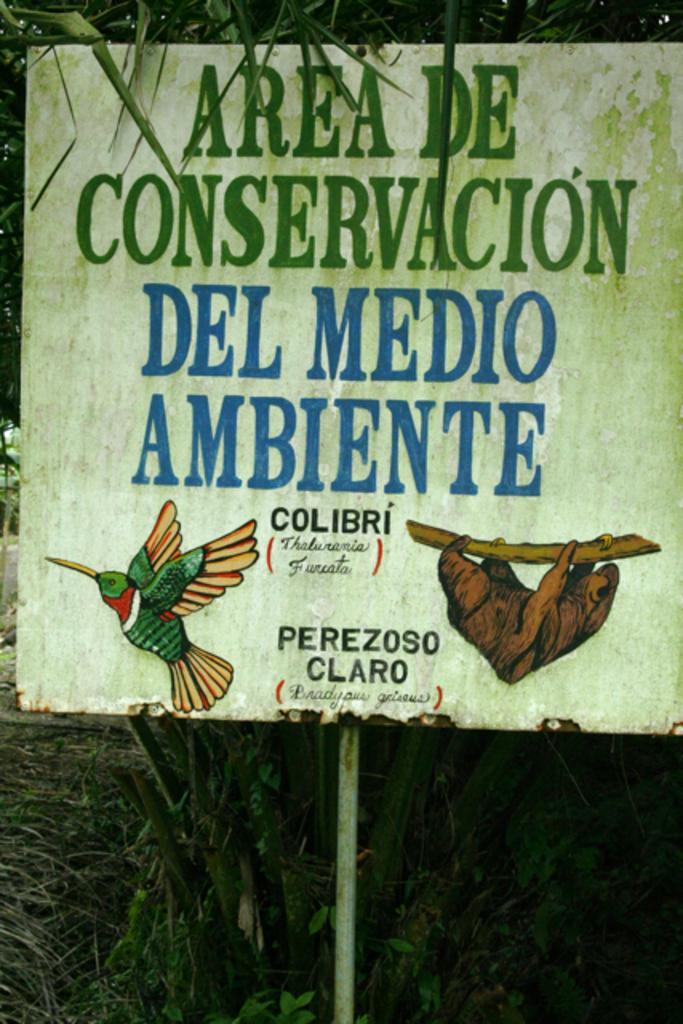Could you give a brief overview of what you see in this image? This picture contains a white color board with some text written on it, in green and blue color. We even see bird drawing on that board. Behind the board, we see the wood and a tree. This picture might be clicked outside the city. 